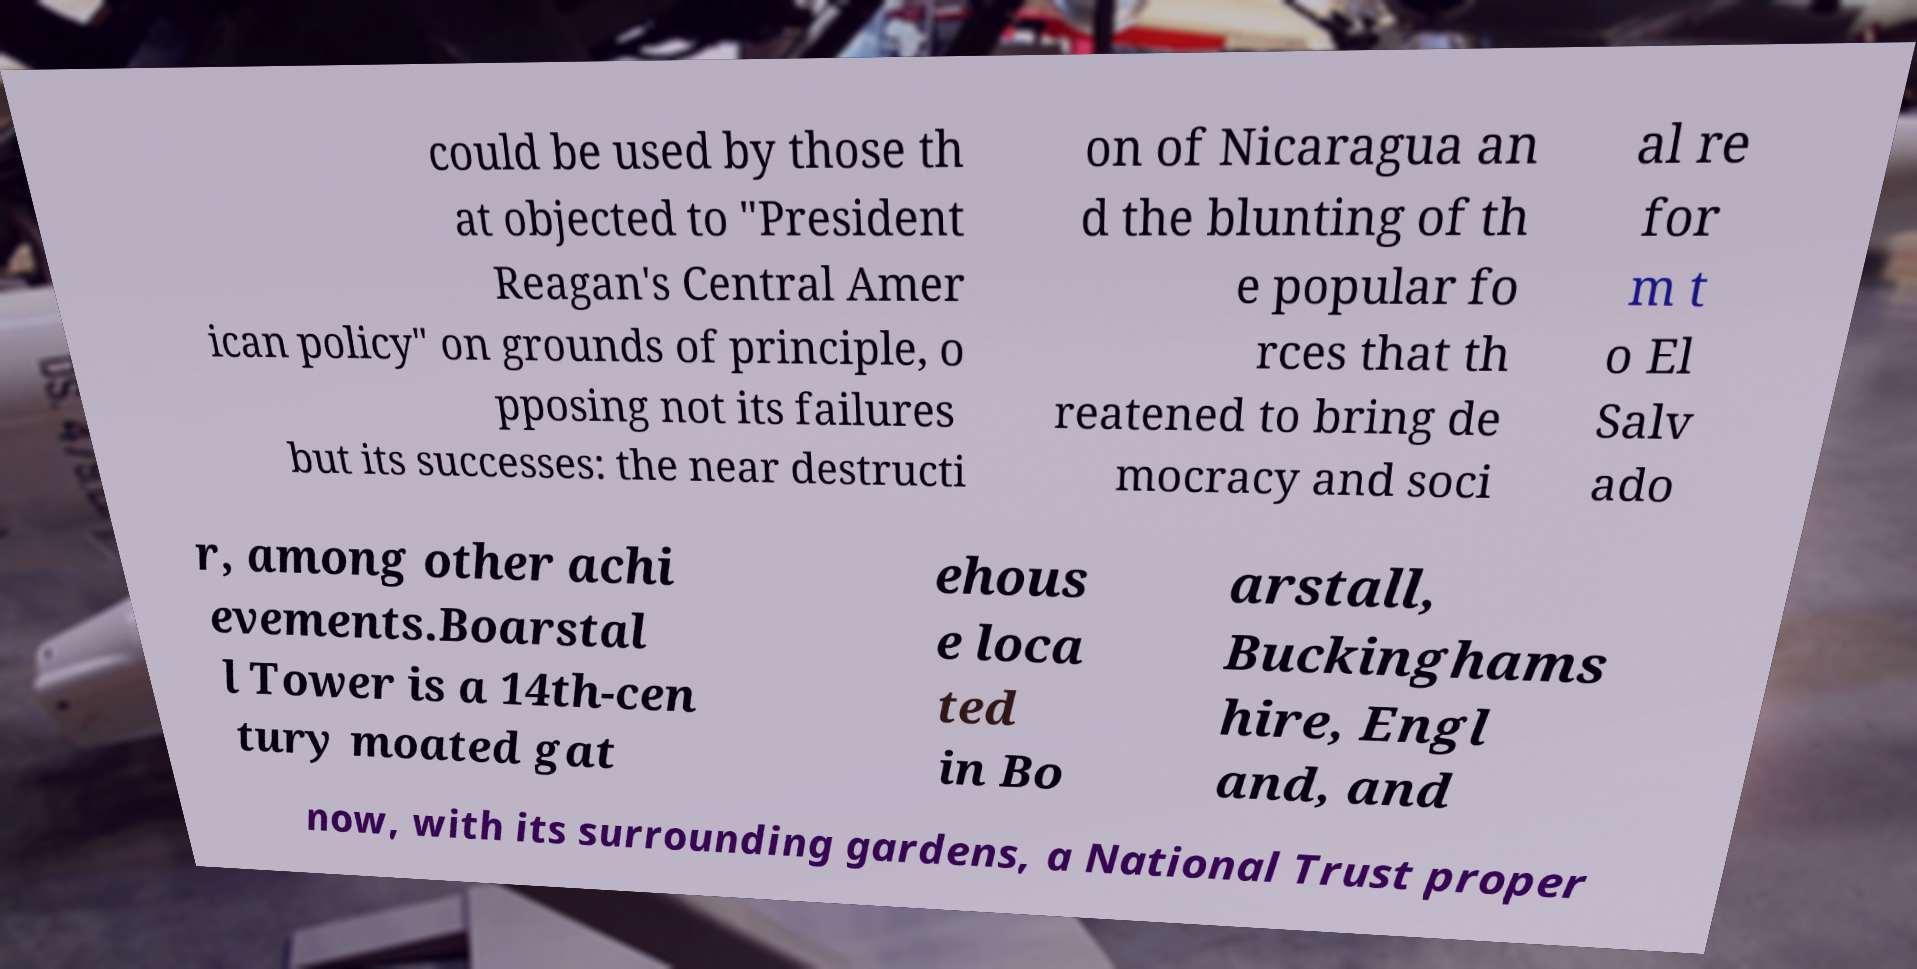Can you read and provide the text displayed in the image?This photo seems to have some interesting text. Can you extract and type it out for me? could be used by those th at objected to "President Reagan's Central Amer ican policy" on grounds of principle, o pposing not its failures but its successes: the near destructi on of Nicaragua an d the blunting of th e popular fo rces that th reatened to bring de mocracy and soci al re for m t o El Salv ado r, among other achi evements.Boarstal l Tower is a 14th-cen tury moated gat ehous e loca ted in Bo arstall, Buckinghams hire, Engl and, and now, with its surrounding gardens, a National Trust proper 